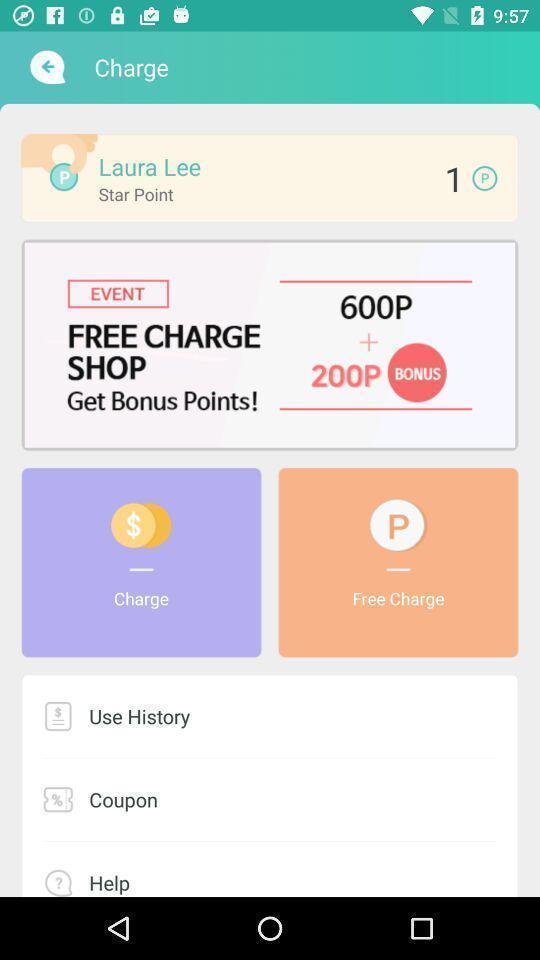Give me a narrative description of this picture. Welcome page. 